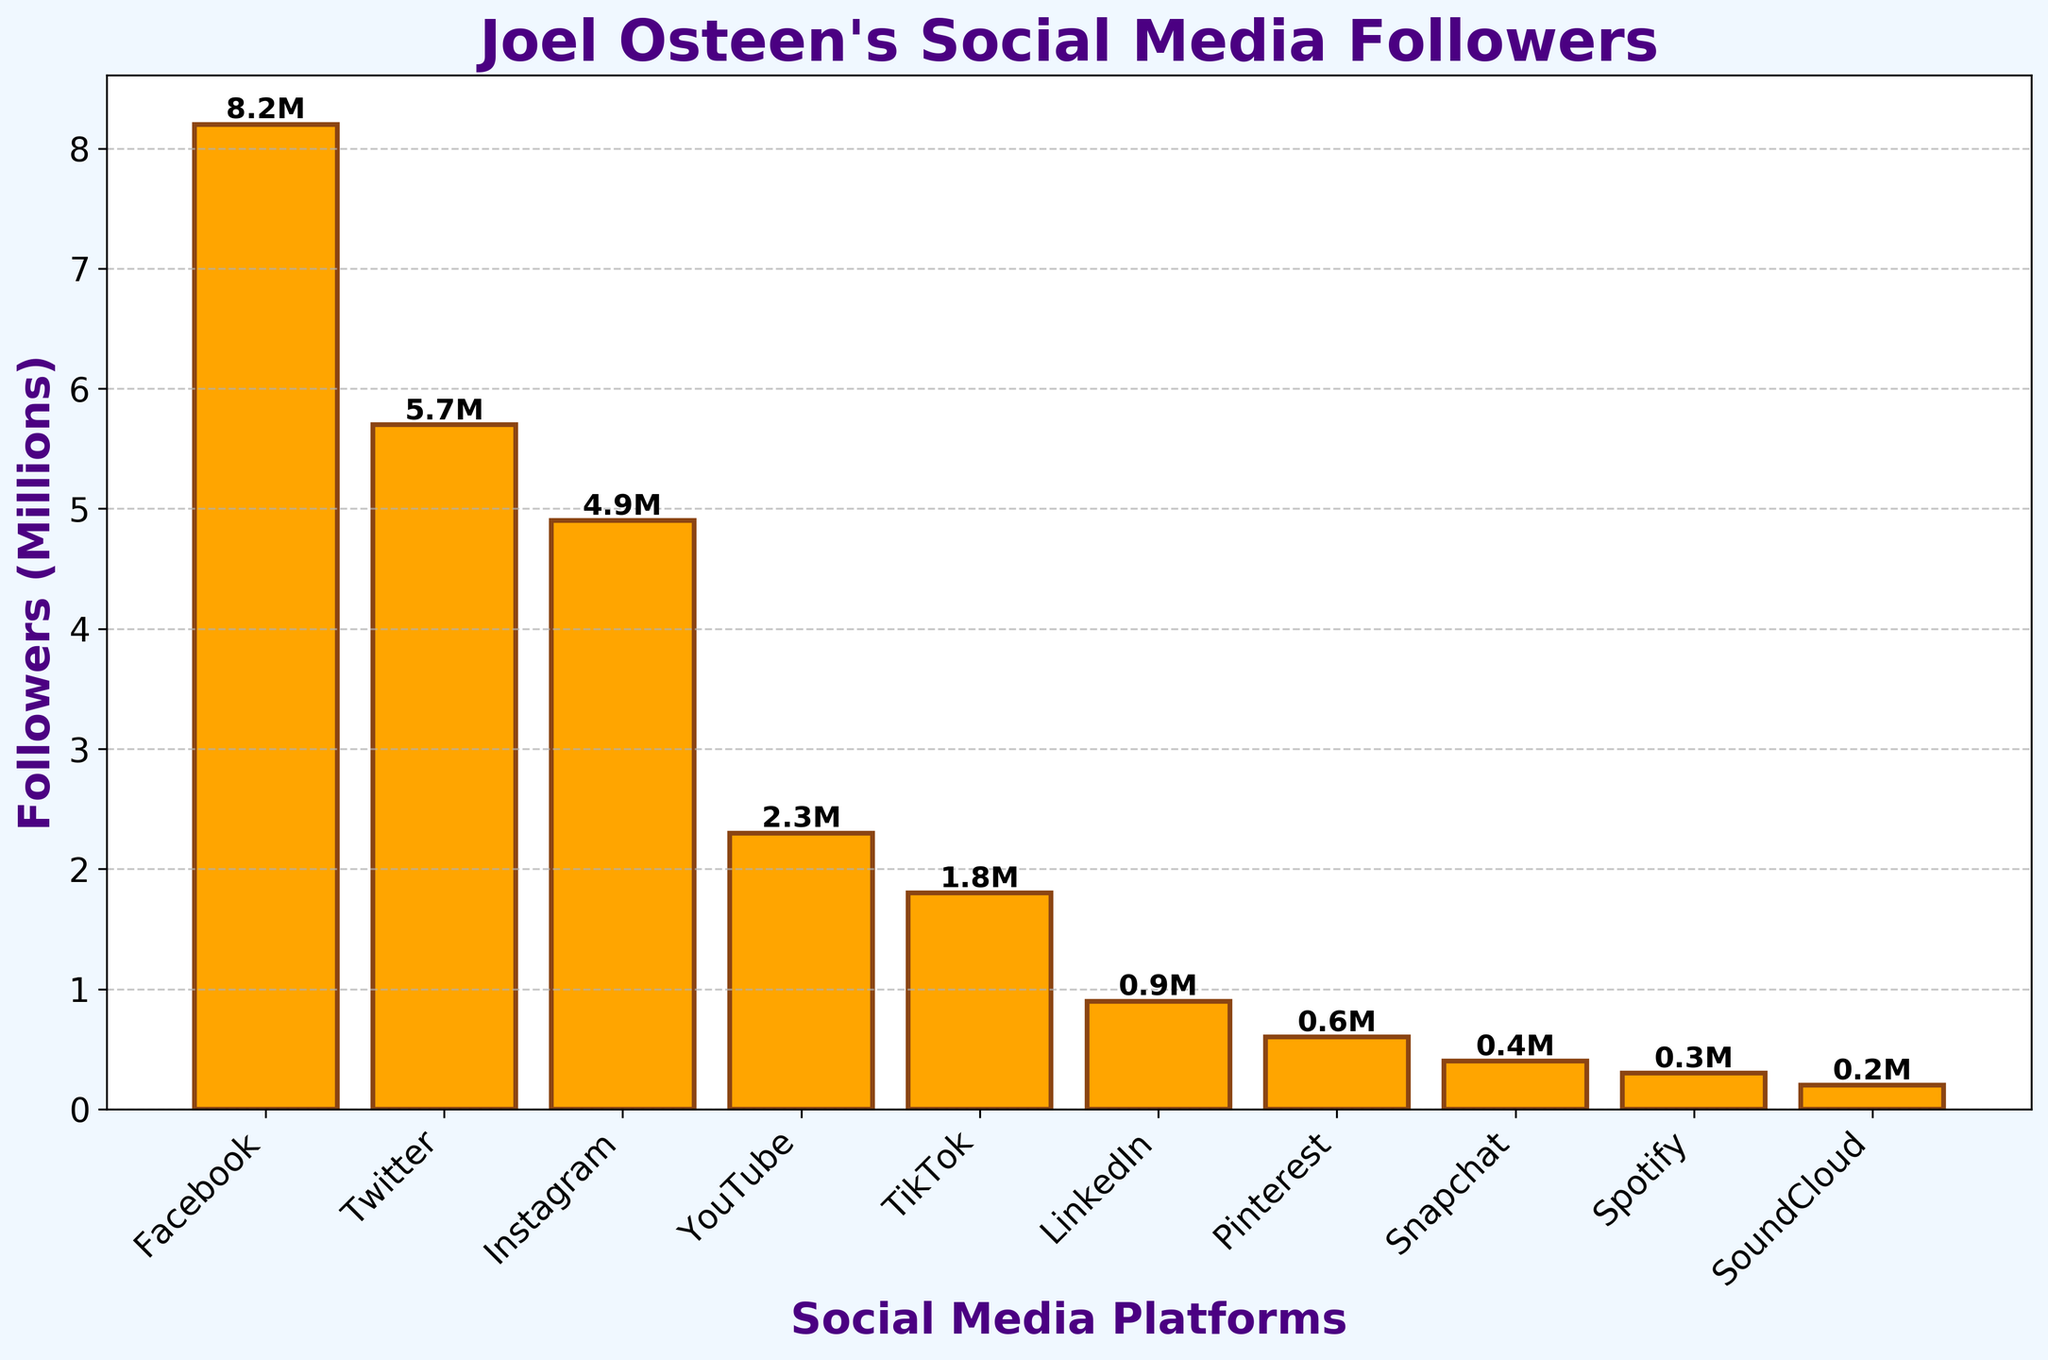Which social media platform has the most followers for Joel Osteen? The bar representing Facebook is the tallest among all the bars, indicating it has the highest number of followers.
Answer: Facebook Which social media platform has the fewest followers for Joel Osteen? The bar representing SoundCloud is the shortest among all the bars, indicating it has the smallest number of followers.
Answer: SoundCloud How many followers does Joel Osteen have on Twitter and Instagram combined? Joel Osteen has 5.7 million followers on Twitter and 4.9 million followers on Instagram. Adding these together, 5.7M + 4.9M = 10.6 million followers.
Answer: 10.6 million What is the difference in the number of followers between Facebook and LinkedIn? Facebook has 8.2 million followers and LinkedIn has 0.9 million followers. The difference is 8.2M - 0.9M = 7.3 million followers.
Answer: 7.3 million Which platform has more followers, TikTok or YouTube? The bar representing YouTube is taller than the bar representing TikTok, indicating YouTube has more followers.
Answer: YouTube What is the total number of followers across all listed platforms? Sum of all the follower counts: 8.2M (Facebook) + 5.7M (Twitter) + 4.9M (Instagram) + 2.3M (YouTube) + 1.8M (TikTok) + 0.9M (LinkedIn) + 0.6M (Pinterest) + 0.4M (Snapchat) + 0.3M (Spotify) + 0.2M (SoundCloud) = 25.3 million followers.
Answer: 25.3 million Which two platforms have the closest number of followers to each other? TikTok has 1.8 million followers and LinkedIn has 0.9 million followers. The difference is 1.8M - 0.9M = 0.9 million followers. While Pinterest has 0.6 million followers and Snapchat has 0.4 million followers with a difference of 0.2 million, being closer.
Answer: Pinterest and Snapchat What is the average number of followers per platform? Total number of followers across all platforms is 25.3 million. There are 10 platforms. The average is 25.3M / 10 = 2.53 million followers per platform.
Answer: 2.53 million What percentage of Joel Osteen’s total social media followers are on Facebook? Facebook has 8.2 million followers. Total followers are 25.3 million. The percentage is (8.2M / 25.3M) * 100 ≈ 32.4%.
Answer: 32.4% Which platform has more followers, Snapchat or Spotify and SoundCloud combined? Snapchat has 0.4 million followers. Spotify and SoundCloud combined have 0.3M + 0.2M = 0.5 million followers.
Answer: Spotify and SoundCloud combined 